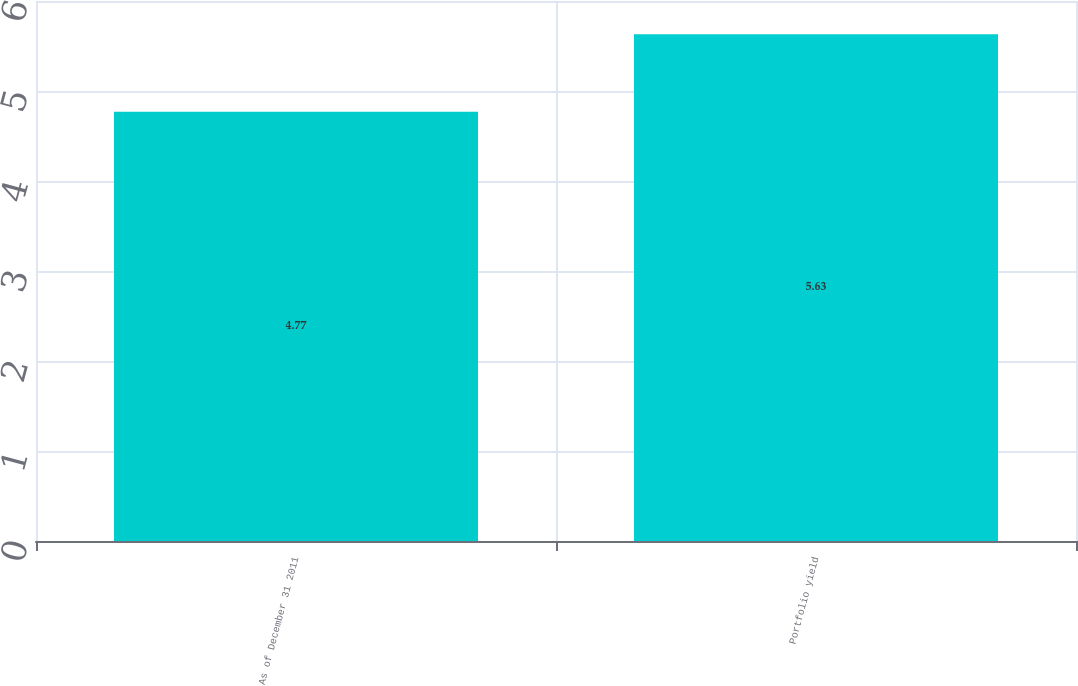Convert chart to OTSL. <chart><loc_0><loc_0><loc_500><loc_500><bar_chart><fcel>As of December 31 2011<fcel>Portfolio yield<nl><fcel>4.77<fcel>5.63<nl></chart> 